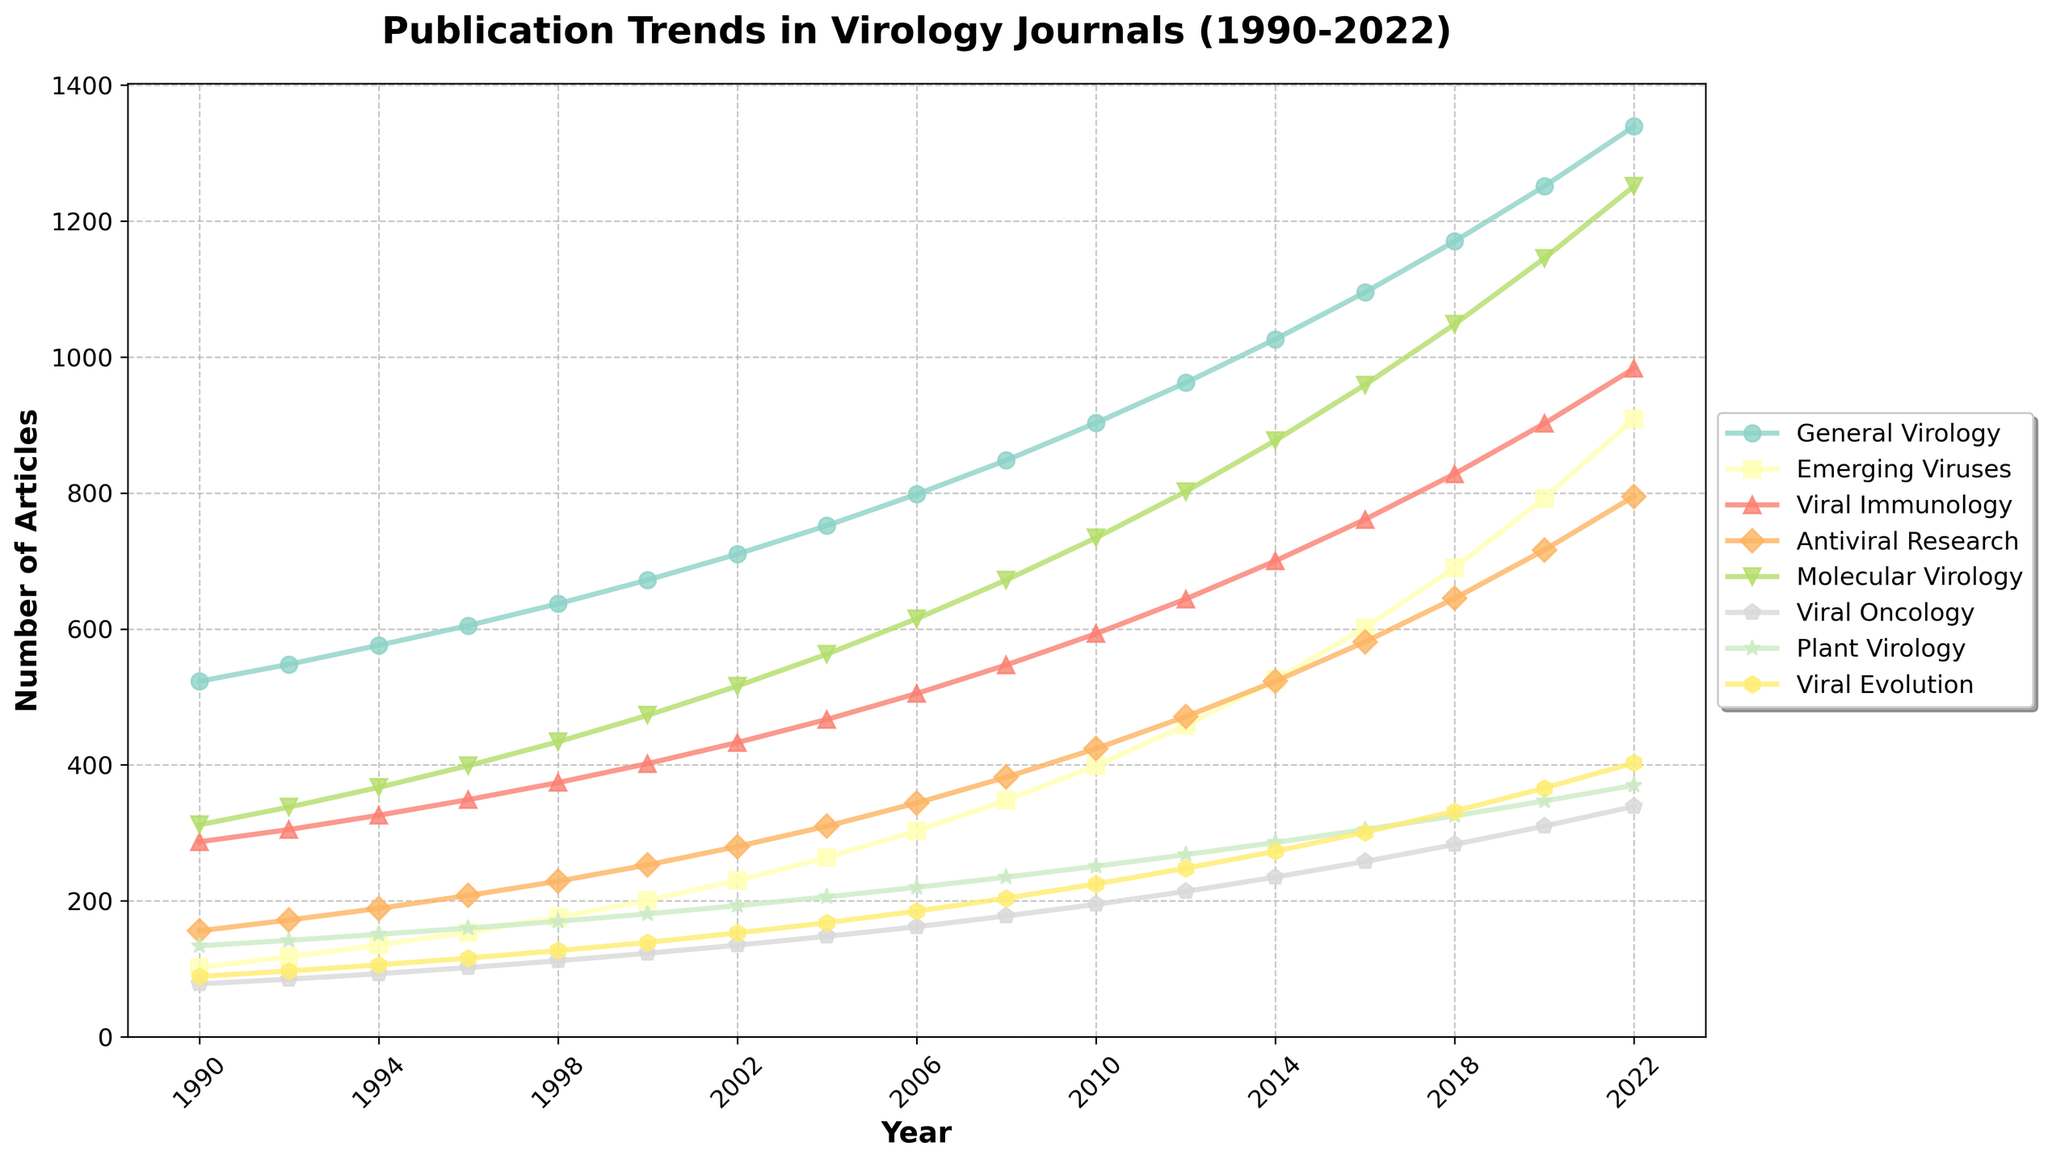Which subfield has the highest number of articles in 2022? By looking at the data points in the figure for the year 2022, the subfield with the highest number of articles can be identified.
Answer: General Virology Between 1998 and 2008, which subfield saw the most significant increase in the number of articles? Subtract the number of articles in 1998 from the number in 2008 for each subfield, then compare the differences. General Virology: 848 - 637 = 211, Emerging Viruses: 348 - 176 = 172, Viral Immunology: 547 - 374 = 173, Antiviral Research: 382 - 229 = 153, Molecular Virology: 672 - 434 = 238, Viral Oncology: 178 - 112 = 66, Plant Virology: 235 - 170 = 65, Viral Evolution: 204 - 127 = 77. The most significant increase is seen in Molecular Virology with an increase of 238 articles.
Answer: Molecular Virology Which subfield consistently had the lowest number of articles from 1990 to 2022? By examining the lowest points for all subfields over each year in the figure, we can identify the subfield with consistently the fewest articles.
Answer: Viral Oncology How did the number of articles in Antiviral Research change from 2000 to 2022? Compare the number of articles in Antiviral Research in the years 2000 and 2022 from the figure. Number of articles in 2000: 253. Number of articles in 2022: 795. Determine the difference: 795 - 253 = 542.
Answer: Increased by 542 On average, how many articles were published in Viral Evolution every six years since 1990? Calculate the number of articles for each six-year interval and find the average. 
1990: 89, 1996: 116, 2002: 153, 2008: 204, 2014: 273, 2020: 366 
Average = (89 + 116 + 153 + 204 + 273 + 366) / 6
Average ≈ 200.17
Answer: ≈ 200.17 Which subfield had the second-highest growth in the number of articles from 1990 to 2022? Calculate the growth for each subfield by subtracting the number of articles in 1990 from the number of articles in 2022, then find the second-highest value. 
1. General Virology: 1339 - 523 = 816 
2. Emerging Viruses: 909 - 102 = 807 
3. Viral Immunology: 983 - 287 = 696 
4. Antiviral Research: 795 - 156 = 639 
5. Molecular Virology: 1251 - 312 = 939 
6. Viral Oncology: 339 - 78 = 261 
7. Plant Virology: 370 - 134 = 236 
8. Viral Evolution: 403 - 89 = 314 
The second-highest growth is in Emerging Viruses with an increase of 807 articles.
Answer: Emerging Viruses 